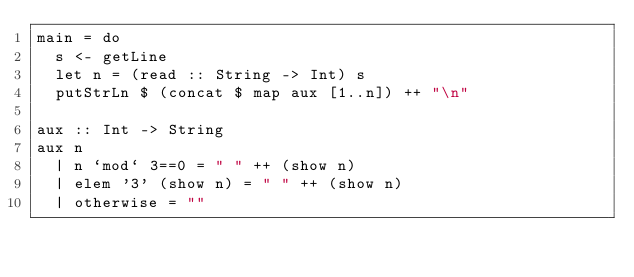<code> <loc_0><loc_0><loc_500><loc_500><_Haskell_>main = do
  s <- getLine
  let n = (read :: String -> Int) s
  putStrLn $ (concat $ map aux [1..n]) ++ "\n"

aux :: Int -> String
aux n
  | n `mod` 3==0 = " " ++ (show n)
  | elem '3' (show n) = " " ++ (show n)
  | otherwise = ""                      </code> 